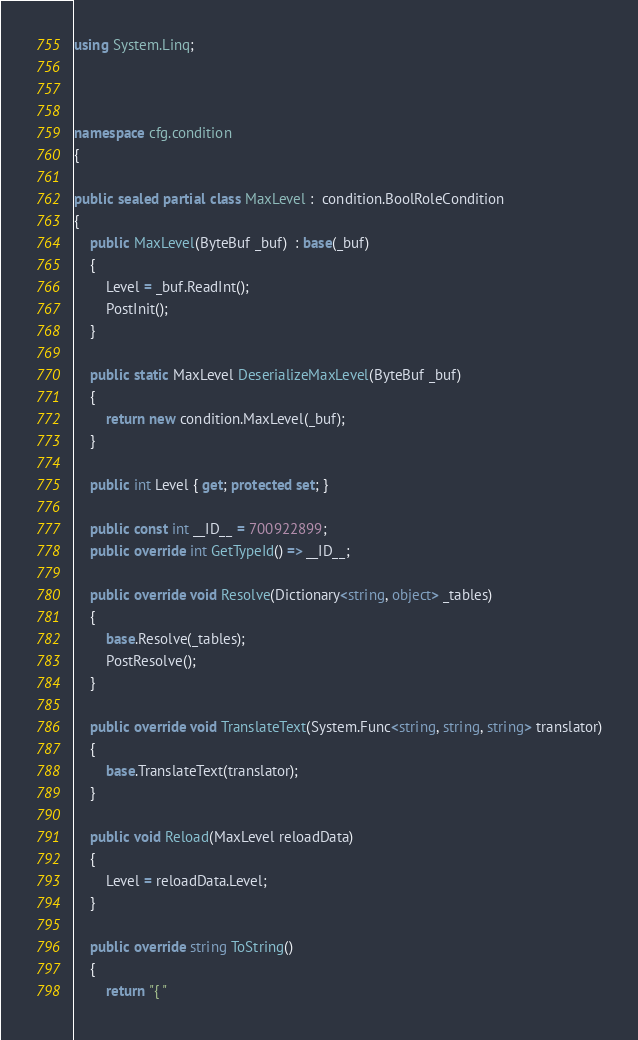<code> <loc_0><loc_0><loc_500><loc_500><_C#_>using System.Linq;



namespace cfg.condition
{

public sealed partial class MaxLevel :  condition.BoolRoleCondition 
{
    public MaxLevel(ByteBuf _buf)  : base(_buf) 
    {
        Level = _buf.ReadInt();
        PostInit();
    }

    public static MaxLevel DeserializeMaxLevel(ByteBuf _buf)
    {
        return new condition.MaxLevel(_buf);
    }

    public int Level { get; protected set; }

    public const int __ID__ = 700922899;
    public override int GetTypeId() => __ID__;

    public override void Resolve(Dictionary<string, object> _tables)
    {
        base.Resolve(_tables);
        PostResolve();
    }

    public override void TranslateText(System.Func<string, string, string> translator)
    {
        base.TranslateText(translator);
    }

    public void Reload(MaxLevel reloadData)
    {
        Level = reloadData.Level;
    }

    public override string ToString()
    {
        return "{ "</code> 